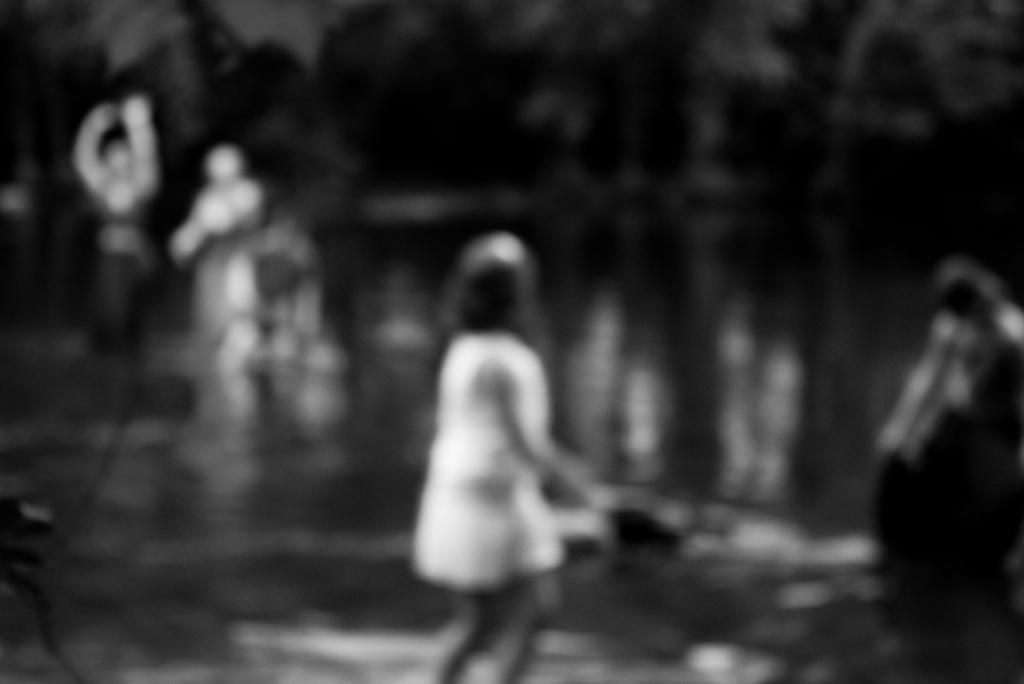Who is the main subject in the image? There is a girl standing in the middle of the image. Where are the other people located in the image? There are people standing on the left side of the image. What can be seen on the right side of the image? There is water visible on the right side of the image. Is the girl in the image a spy? There is no indication in the image that the girl is a spy, as the image does not provide any information about her occupation or activities. 